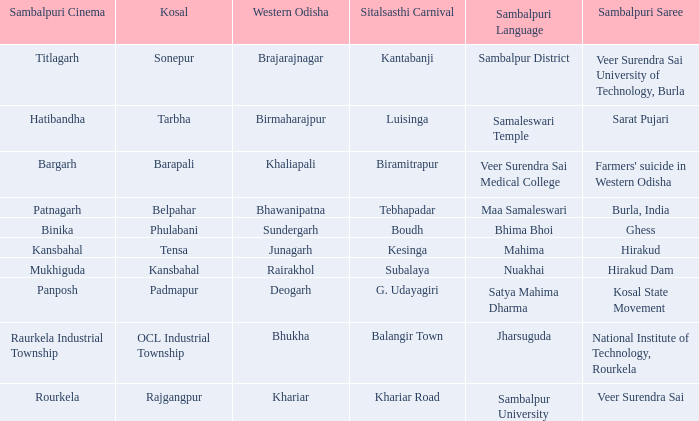I'm looking to parse the entire table for insights. Could you assist me with that? {'header': ['Sambalpuri Cinema', 'Kosal', 'Western Odisha', 'Sitalsasthi Carnival', 'Sambalpuri Language', 'Sambalpuri Saree'], 'rows': [['Titlagarh', 'Sonepur', 'Brajarajnagar', 'Kantabanji', 'Sambalpur District', 'Veer Surendra Sai University of Technology, Burla'], ['Hatibandha', 'Tarbha', 'Birmaharajpur', 'Luisinga', 'Samaleswari Temple', 'Sarat Pujari'], ['Bargarh', 'Barapali', 'Khaliapali', 'Biramitrapur', 'Veer Surendra Sai Medical College', "Farmers' suicide in Western Odisha"], ['Patnagarh', 'Belpahar', 'Bhawanipatna', 'Tebhapadar', 'Maa Samaleswari', 'Burla, India'], ['Binika', 'Phulabani', 'Sundergarh', 'Boudh', 'Bhima Bhoi', 'Ghess'], ['Kansbahal', 'Tensa', 'Junagarh', 'Kesinga', 'Mahima', 'Hirakud'], ['Mukhiguda', 'Kansbahal', 'Rairakhol', 'Subalaya', 'Nuakhai', 'Hirakud Dam'], ['Panposh', 'Padmapur', 'Deogarh', 'G. Udayagiri', 'Satya Mahima Dharma', 'Kosal State Movement'], ['Raurkela Industrial Township', 'OCL Industrial Township', 'Bhukha', 'Balangir Town', 'Jharsuguda', 'National Institute of Technology, Rourkela'], ['Rourkela', 'Rajgangpur', 'Khariar', 'Khariar Road', 'Sambalpur University', 'Veer Surendra Sai']]} What is the Kosal with a balangir town sitalsasthi carnival? OCL Industrial Township. 